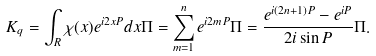<formula> <loc_0><loc_0><loc_500><loc_500>K _ { q } = \int _ { R } \chi ( x ) e ^ { i 2 x P } d x \Pi = \sum _ { m = 1 } ^ { n } e ^ { i 2 m P } \Pi = \frac { e ^ { i ( 2 n + 1 ) P } - e ^ { i P } } { 2 i \sin P } \Pi .</formula> 